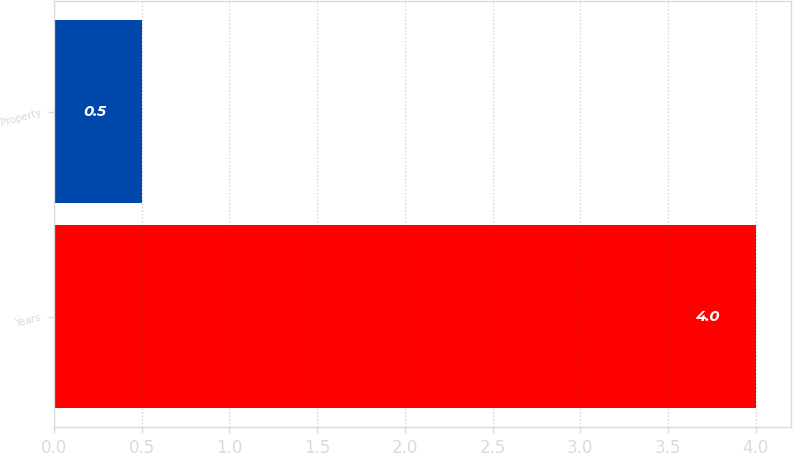Convert chart. <chart><loc_0><loc_0><loc_500><loc_500><bar_chart><fcel>Years<fcel>Property<nl><fcel>4<fcel>0.5<nl></chart> 